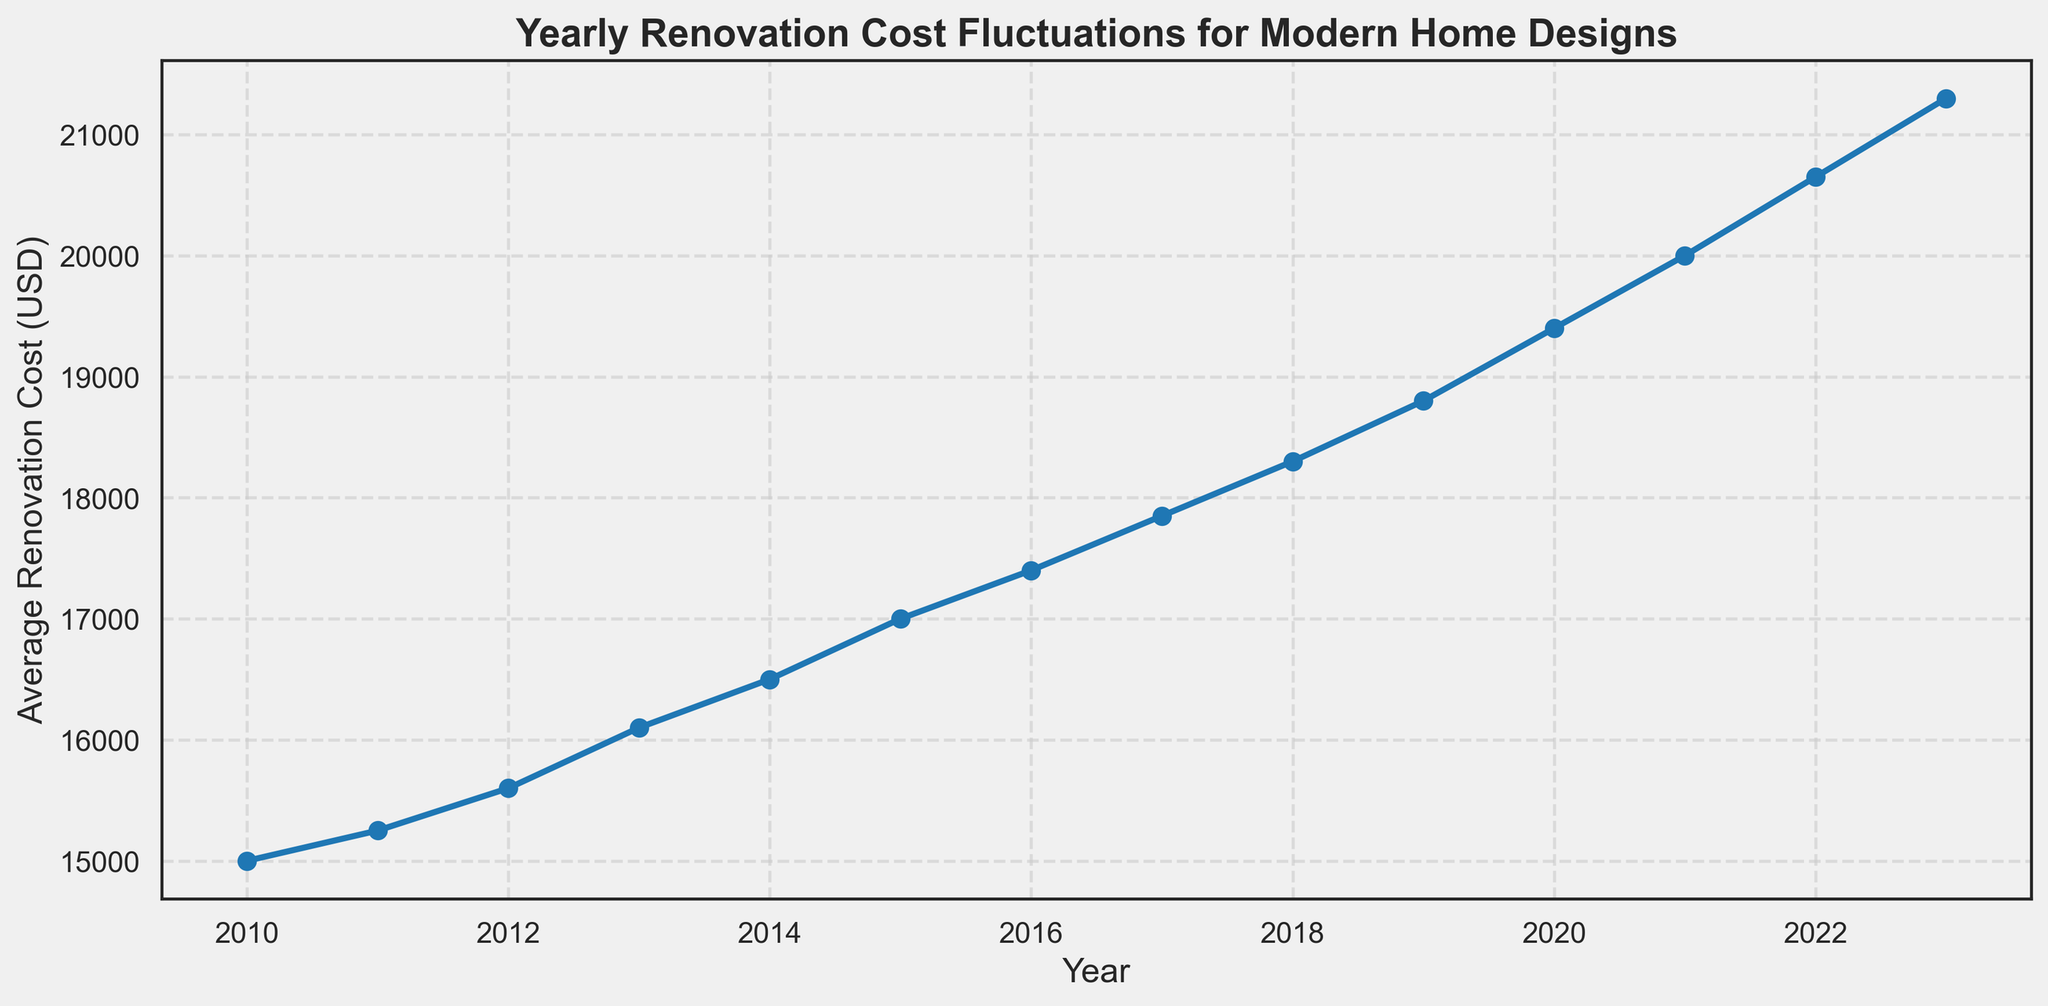What was the average renovation cost in 2015? Locate the year 2015 along the x-axis, then find the corresponding point on the line and check its y-axis value, which represents the average renovation cost.
Answer: 17000 Which year experienced the highest average renovation cost? Look for the highest point on the line chart and check the corresponding year on the x-axis.
Answer: 2023 How much did the average renovation cost increase from 2010 to 2023? Subtract the cost in 2010 (15000) from the cost in 2023 (21300).
Answer: 6300 Which year had a higher average renovation cost, 2017 or 2019? Compare the y-axis values associated with the years 2017 and 2019; find the year with the higher value.
Answer: 2019 By how much did the average renovation cost increase between 2011 and 2015? Subtract the cost in 2011 (15250) from the cost in 2015 (17000).
Answer: 1750 What is the average renovation cost over the entire period (2010-2023)? Sum the renovation costs from 2010 to 2023 (15000 + 15250 + 15600 + 16100 + 16500 + 17000 + 17400 + 17850 + 18300 + 18800 + 19400 + 20000 + 20650 + 21300) and then divide by the number of years (14).
Answer: 17910.71 Which year showed the first instance of the average renovation cost exceeding 18000 USD? Identify the first year on the x-axis where the y-axis value crosses 18000 USD.
Answer: 2018 Did the average renovation cost increase continuously every year from 2010 to 2023? Inspect the line chart to see if the values consistently rise each year without any decrease.
Answer: Yes What was the smallest year-over-year increase in the average renovation cost? Calculate the year-over-year increases for each consecutive pair of years and identify the smallest value.
Answer: 250 (between 2010 and 2011) 